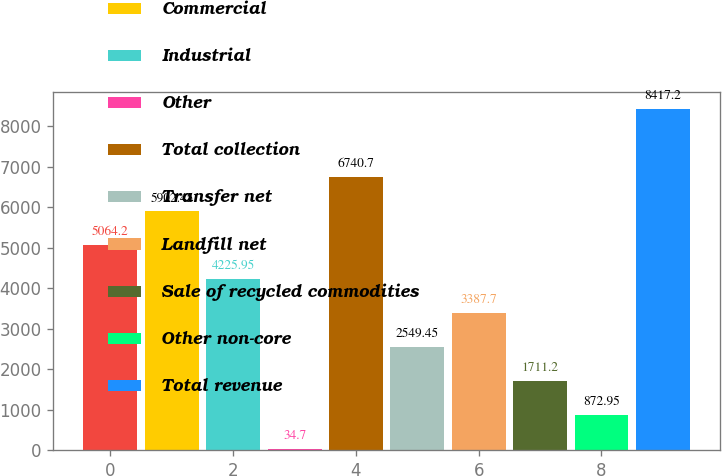Convert chart to OTSL. <chart><loc_0><loc_0><loc_500><loc_500><bar_chart><fcel>Residential<fcel>Commercial<fcel>Industrial<fcel>Other<fcel>Total collection<fcel>Transfer net<fcel>Landfill net<fcel>Sale of recycled commodities<fcel>Other non-core<fcel>Total revenue<nl><fcel>5064.2<fcel>5902.45<fcel>4225.95<fcel>34.7<fcel>6740.7<fcel>2549.45<fcel>3387.7<fcel>1711.2<fcel>872.95<fcel>8417.2<nl></chart> 